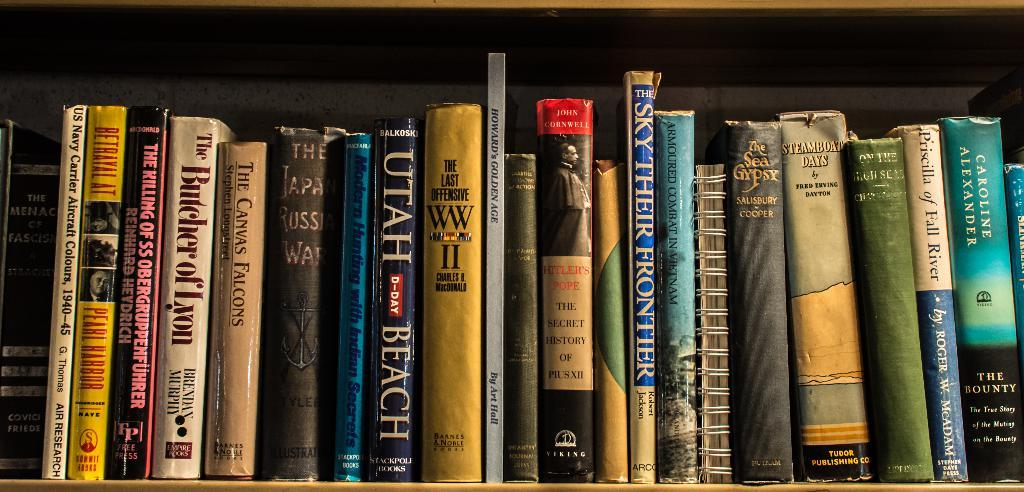<image>
Give a short and clear explanation of the subsequent image. A row of books on a shelf include The Sky Their Frontier, The Sea Gypsy, and Priscilla of Fall River. 